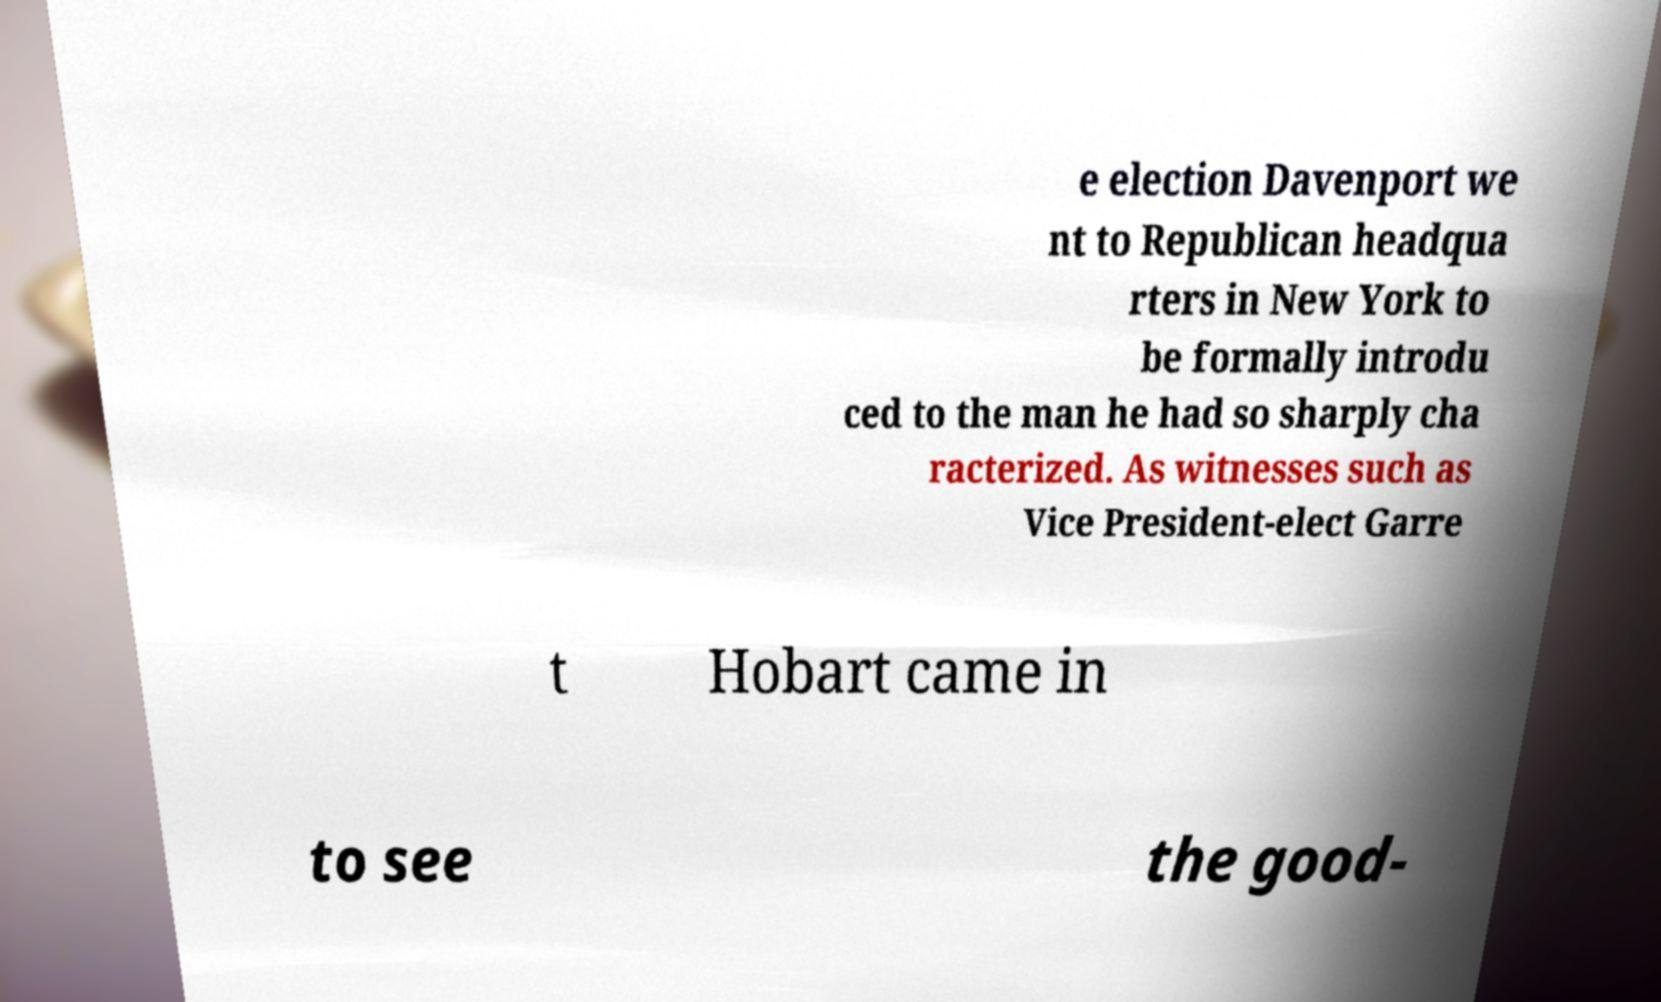Please read and relay the text visible in this image. What does it say? e election Davenport we nt to Republican headqua rters in New York to be formally introdu ced to the man he had so sharply cha racterized. As witnesses such as Vice President-elect Garre t Hobart came in to see the good- 